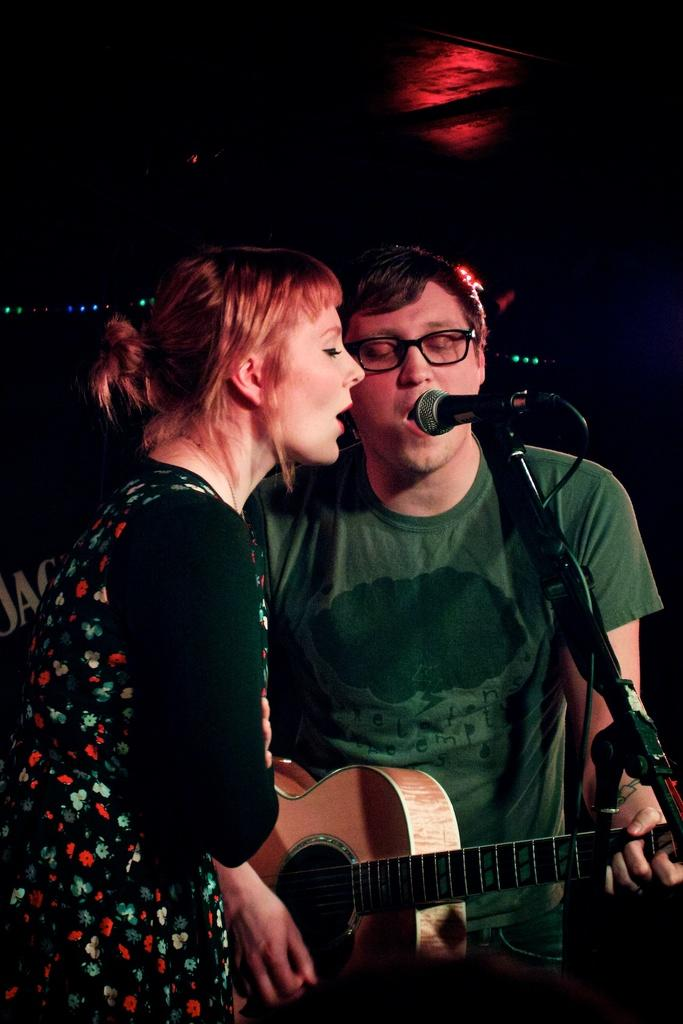Who are the people in the image? There is a man and a woman in the image. What are the man and woman doing in the image? The man and woman are singing a song in the image. What object is in front of them? There is a microphone in front of the man and woman. What instrument is the man holding? The man is holding a guitar in the image. What type of fireman is visible in the image? There is no fireman present in the image. What color is the ink used by the woman in the image? There is no ink or writing activity depicted in the image. 